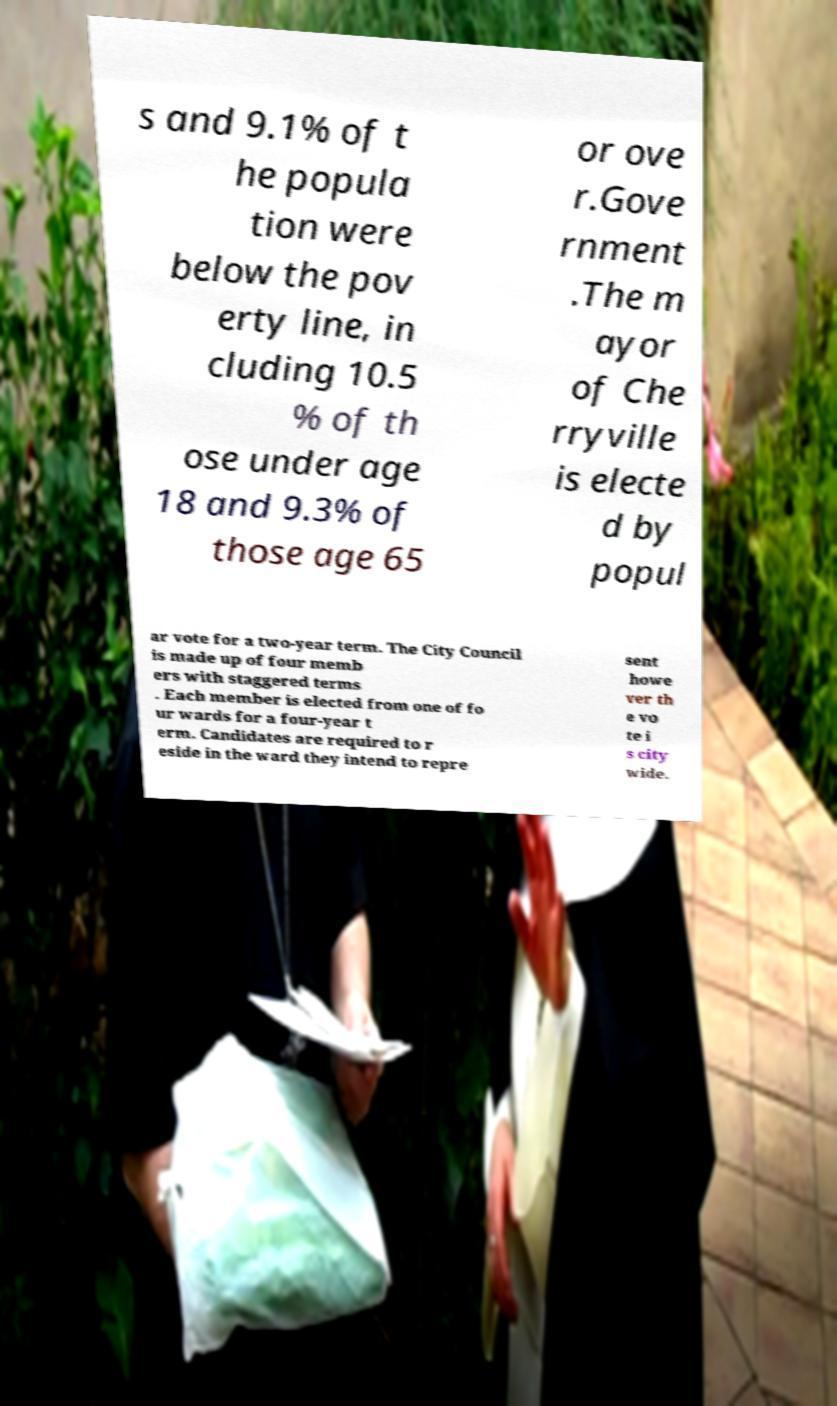I need the written content from this picture converted into text. Can you do that? s and 9.1% of t he popula tion were below the pov erty line, in cluding 10.5 % of th ose under age 18 and 9.3% of those age 65 or ove r.Gove rnment .The m ayor of Che rryville is electe d by popul ar vote for a two-year term. The City Council is made up of four memb ers with staggered terms . Each member is elected from one of fo ur wards for a four-year t erm. Candidates are required to r eside in the ward they intend to repre sent howe ver th e vo te i s city wide. 